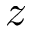<formula> <loc_0><loc_0><loc_500><loc_500>z</formula> 